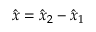Convert formula to latex. <formula><loc_0><loc_0><loc_500><loc_500>\hat { x } = \hat { x } _ { 2 } - \hat { x } _ { 1 }</formula> 